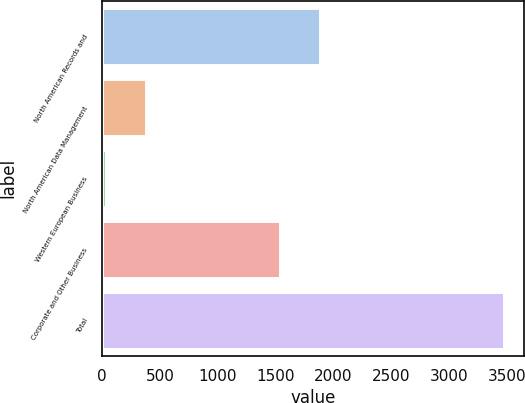Convert chart. <chart><loc_0><loc_0><loc_500><loc_500><bar_chart><fcel>North American Records and<fcel>North American Data Management<fcel>Western European Business<fcel>Corporate and Other Business<fcel>Total<nl><fcel>1886.2<fcel>377.2<fcel>33<fcel>1542<fcel>3475<nl></chart> 